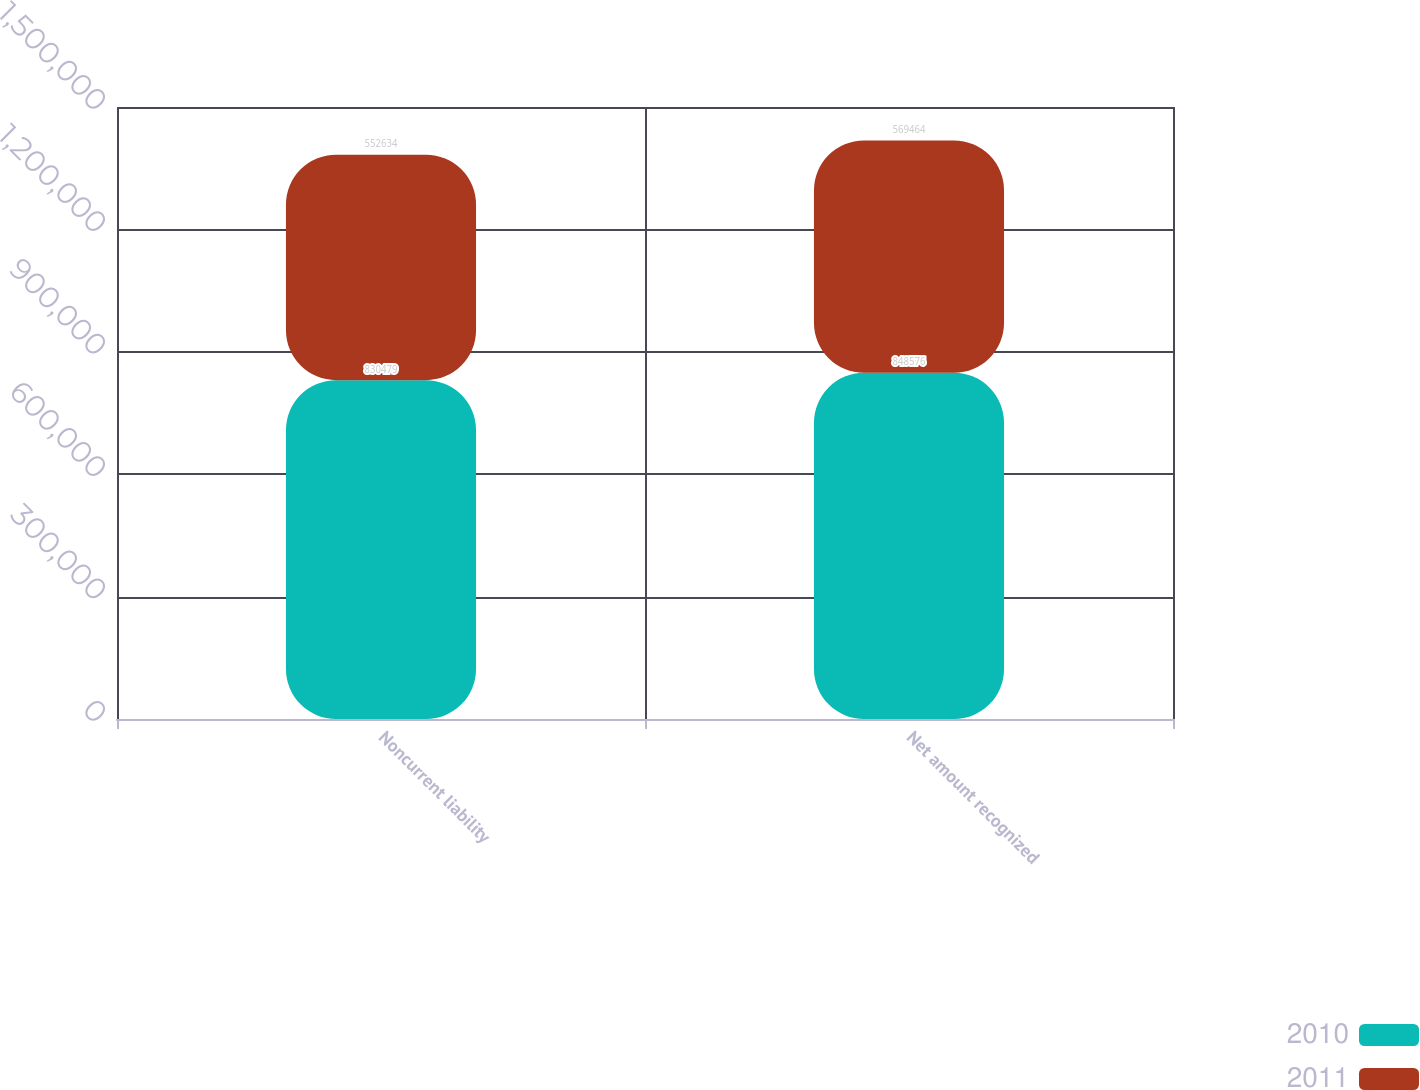Convert chart to OTSL. <chart><loc_0><loc_0><loc_500><loc_500><stacked_bar_chart><ecel><fcel>Noncurrent liability<fcel>Net amount recognized<nl><fcel>2010<fcel>830479<fcel>848576<nl><fcel>2011<fcel>552634<fcel>569464<nl></chart> 